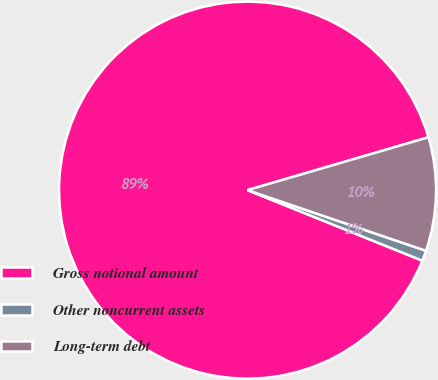Convert chart. <chart><loc_0><loc_0><loc_500><loc_500><pie_chart><fcel>Gross notional amount<fcel>Other noncurrent assets<fcel>Long-term debt<nl><fcel>89.37%<fcel>0.89%<fcel>9.74%<nl></chart> 